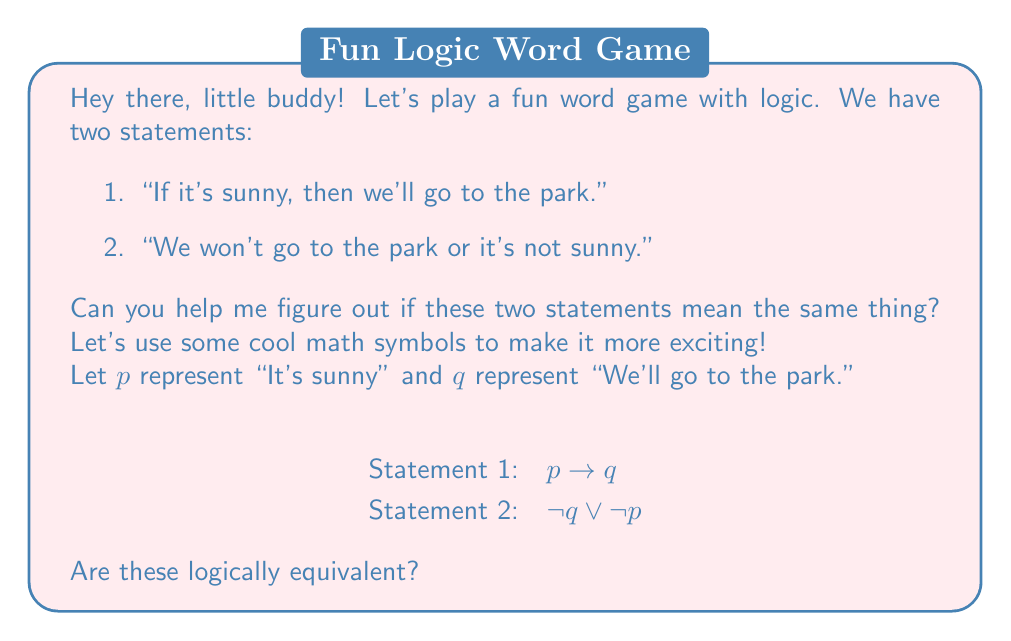Show me your answer to this math problem. Alright, let's break this down step-by-step, using some neat logic tricks:

1. We start with Statement 1: $p \rightarrow q$

2. To show equivalence, we can convert this to its logically equivalent form using the material implication rule:
   $p \rightarrow q \equiv \neg p \lor q$

3. Now, let's apply De Morgan's Law to the right side of Statement 2:
   $\neg q \lor \neg p \equiv \neg(q \land p)$

4. We can swap the order of $q$ and $p$ (commutative property):
   $\neg(q \land p) \equiv \neg(p \land q)$

5. Applying De Morgan's Law again:
   $\neg(p \land q) \equiv \neg p \lor \neg q$

6. Now, we can use the double negation rule on $q$:
   $\neg p \lor \neg q \equiv \neg p \lor q$

7. Look at what we have now! $\neg p \lor q$ is exactly what we got from Statement 1 in step 2.

So, we've shown that both statements can be reduced to the same logical form: $\neg p \lor q$
Answer: Yes, the statements are logically equivalent. 